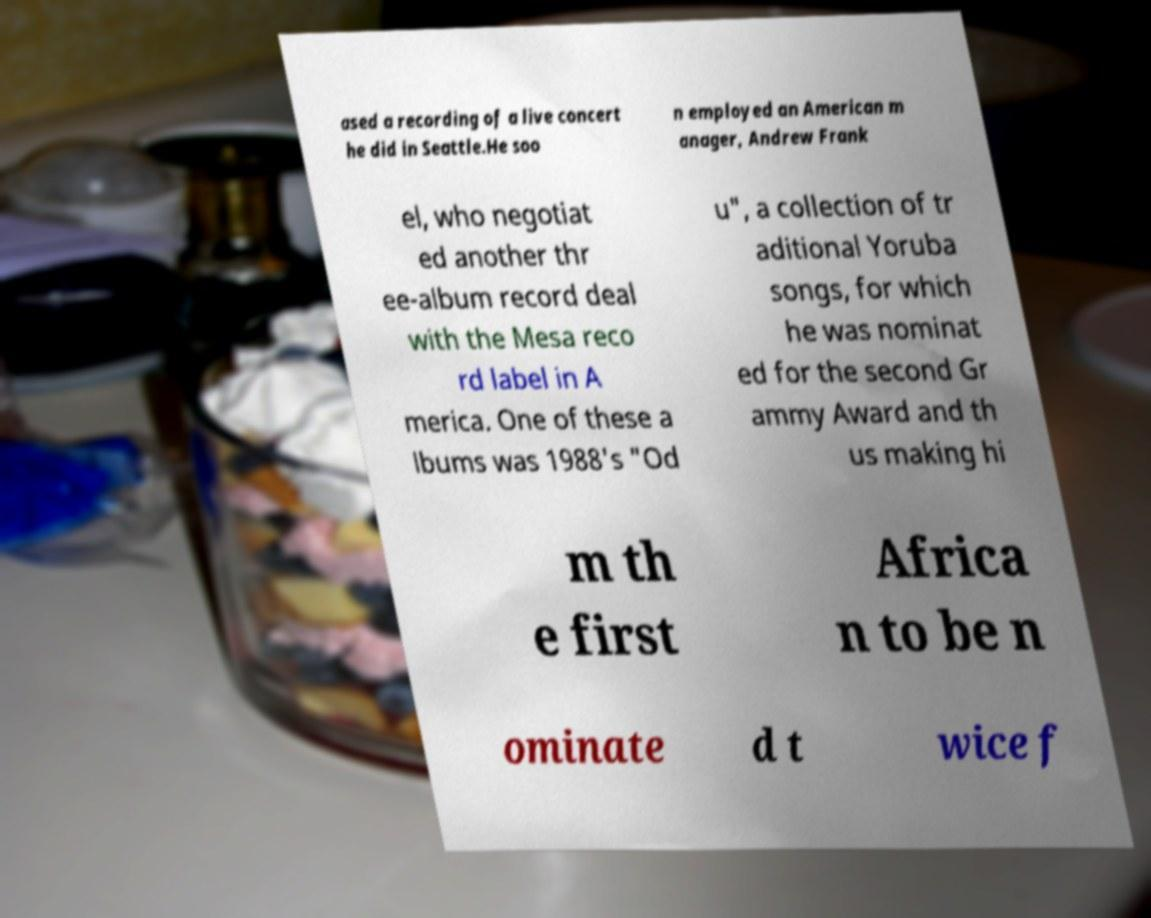There's text embedded in this image that I need extracted. Can you transcribe it verbatim? ased a recording of a live concert he did in Seattle.He soo n employed an American m anager, Andrew Frank el, who negotiat ed another thr ee-album record deal with the Mesa reco rd label in A merica. One of these a lbums was 1988's "Od u", a collection of tr aditional Yoruba songs, for which he was nominat ed for the second Gr ammy Award and th us making hi m th e first Africa n to be n ominate d t wice f 